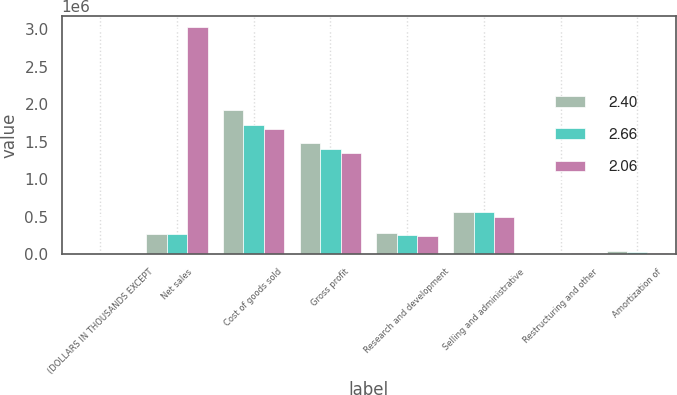Convert chart to OTSL. <chart><loc_0><loc_0><loc_500><loc_500><stacked_bar_chart><ecel><fcel>(DOLLARS IN THOUSANDS EXCEPT<fcel>Net sales<fcel>Cost of goods sold<fcel>Gross profit<fcel>Research and development<fcel>Selling and administrative<fcel>Restructuring and other<fcel>Amortization of<nl><fcel>2.4<fcel>2017<fcel>270144<fcel>1.91972e+06<fcel>1.479e+06<fcel>286026<fcel>557311<fcel>19711<fcel>34694<nl><fcel>2.66<fcel>2016<fcel>270144<fcel>1.71728e+06<fcel>1.39907e+06<fcel>254263<fcel>566224<fcel>1700<fcel>23763<nl><fcel>2.06<fcel>2015<fcel>3.02319e+06<fcel>1.67159e+06<fcel>1.3516e+06<fcel>246101<fcel>494517<fcel>7594<fcel>15040<nl></chart> 